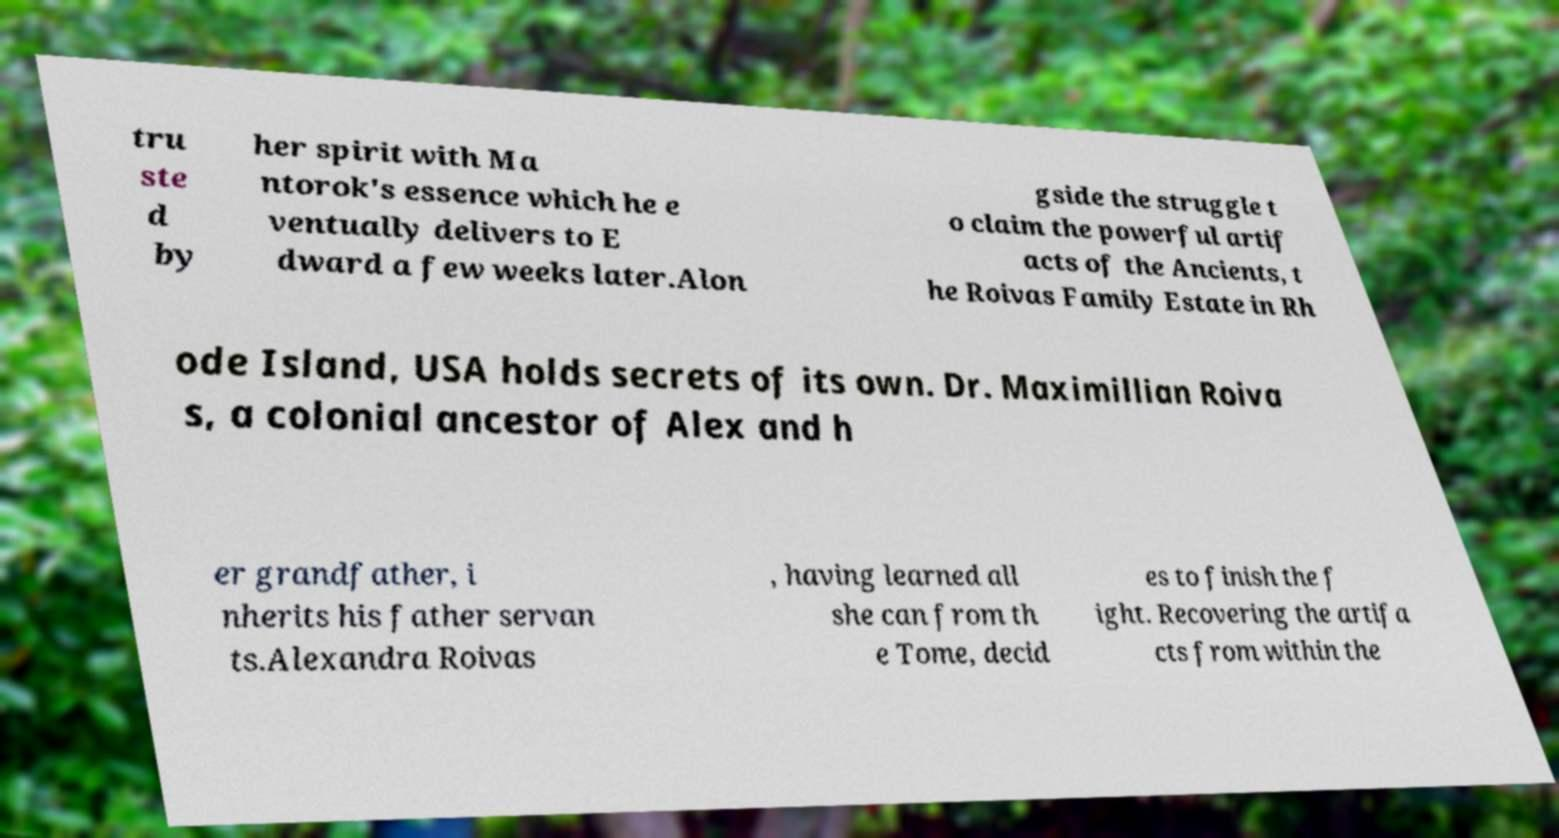For documentation purposes, I need the text within this image transcribed. Could you provide that? tru ste d by her spirit with Ma ntorok's essence which he e ventually delivers to E dward a few weeks later.Alon gside the struggle t o claim the powerful artif acts of the Ancients, t he Roivas Family Estate in Rh ode Island, USA holds secrets of its own. Dr. Maximillian Roiva s, a colonial ancestor of Alex and h er grandfather, i nherits his father servan ts.Alexandra Roivas , having learned all she can from th e Tome, decid es to finish the f ight. Recovering the artifa cts from within the 